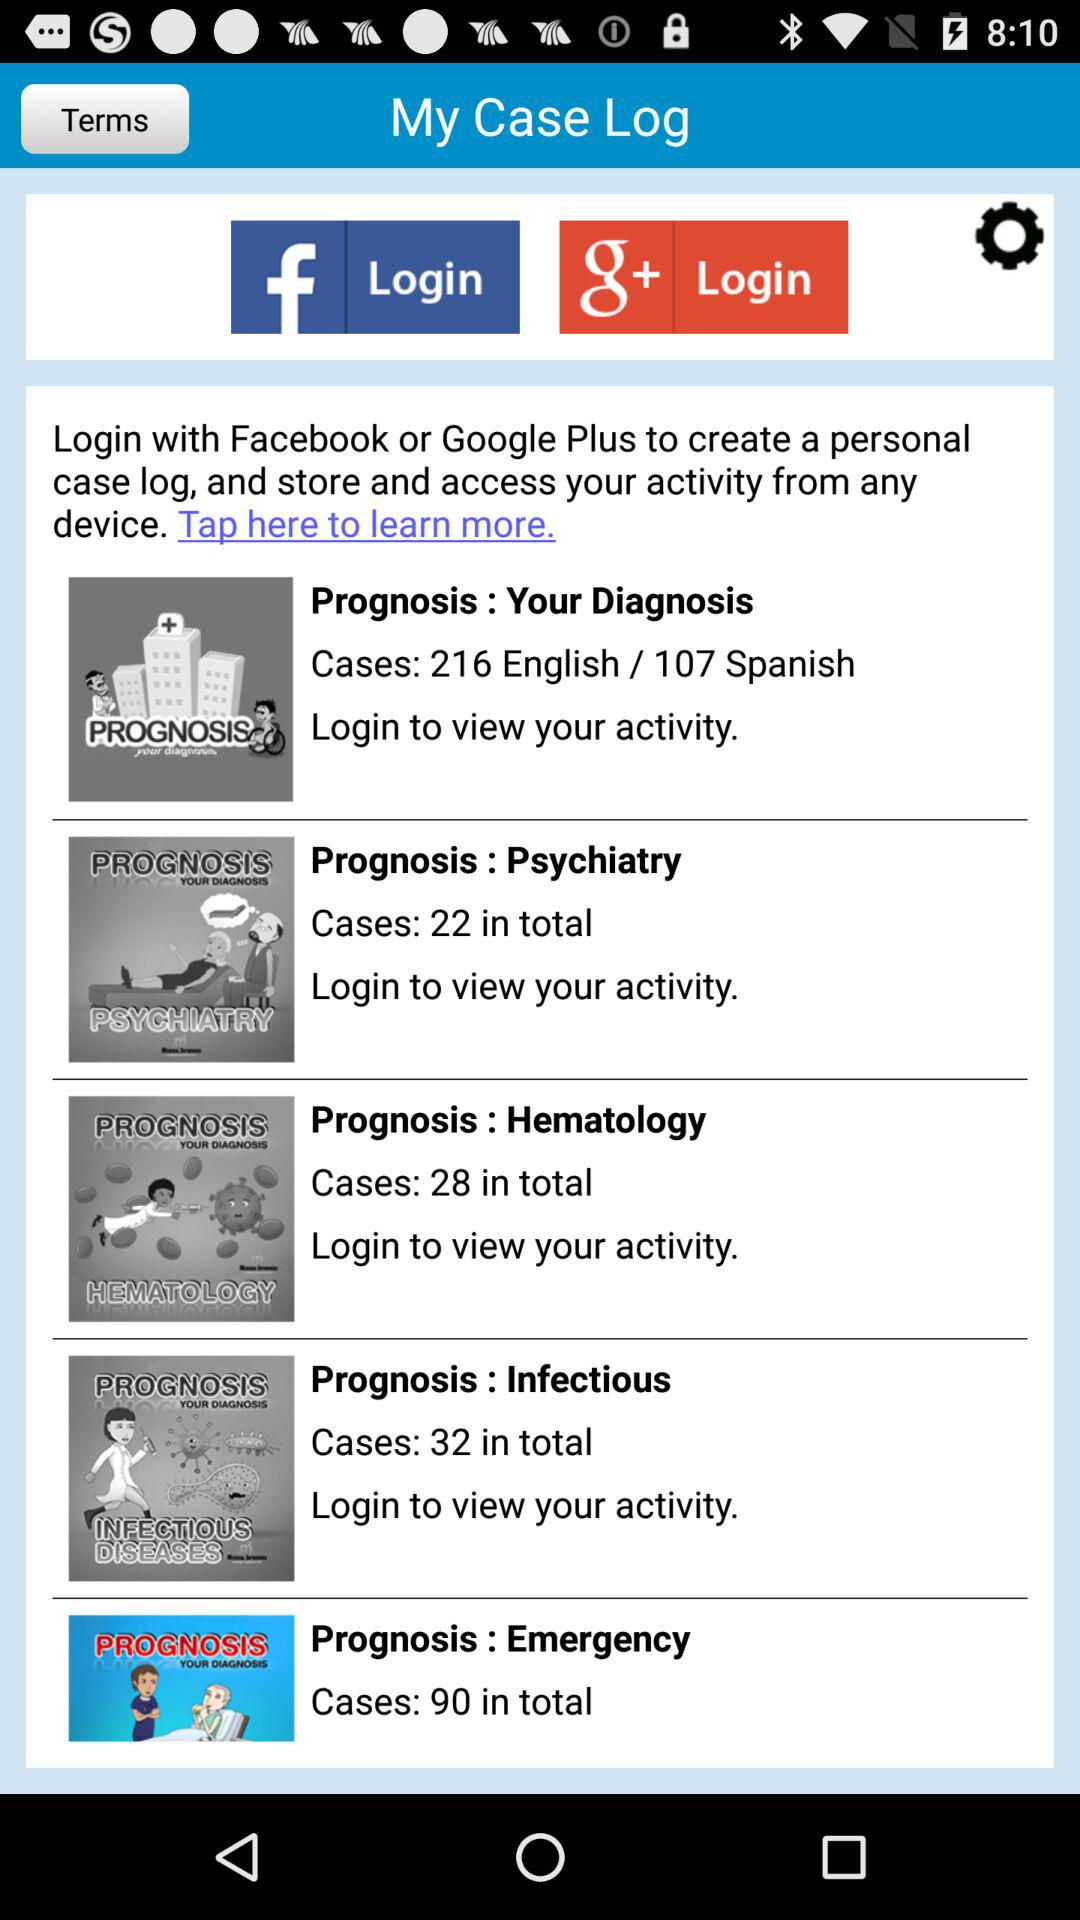Which languages is "Prognosis : Psychiatry" available in?
When the provided information is insufficient, respond with <no answer>. <no answer> 